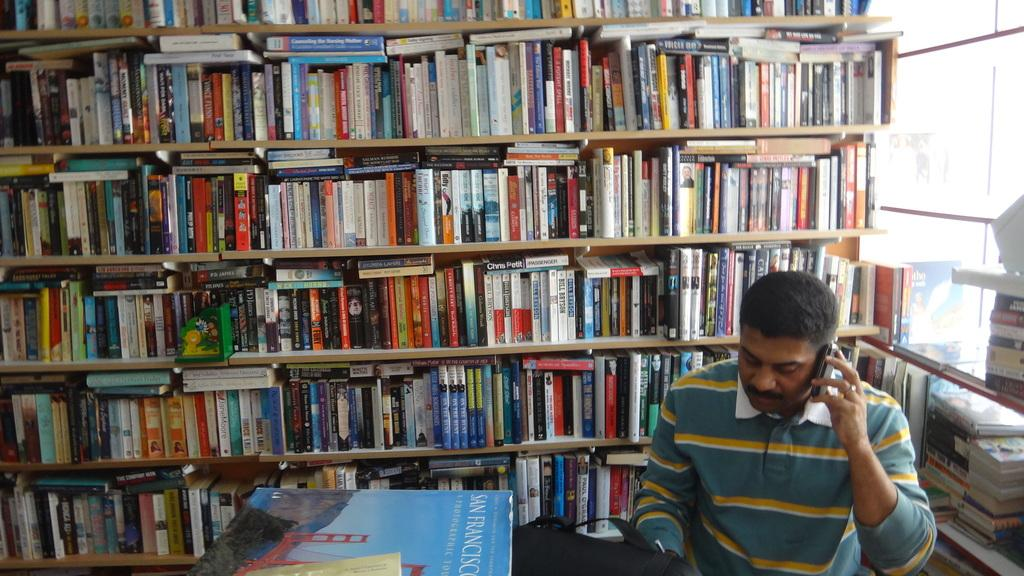<image>
Create a compact narrative representing the image presented. Man on a cell phone in a library surrounded by books and  San Francisco book on table 